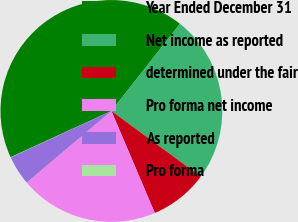Convert chart to OTSL. <chart><loc_0><loc_0><loc_500><loc_500><pie_chart><fcel>Year Ended December 31<fcel>Net income as reported<fcel>determined under the fair<fcel>Pro forma net income<fcel>As reported<fcel>Pro forma<nl><fcel>42.47%<fcel>24.47%<fcel>8.52%<fcel>20.23%<fcel>4.28%<fcel>0.04%<nl></chart> 